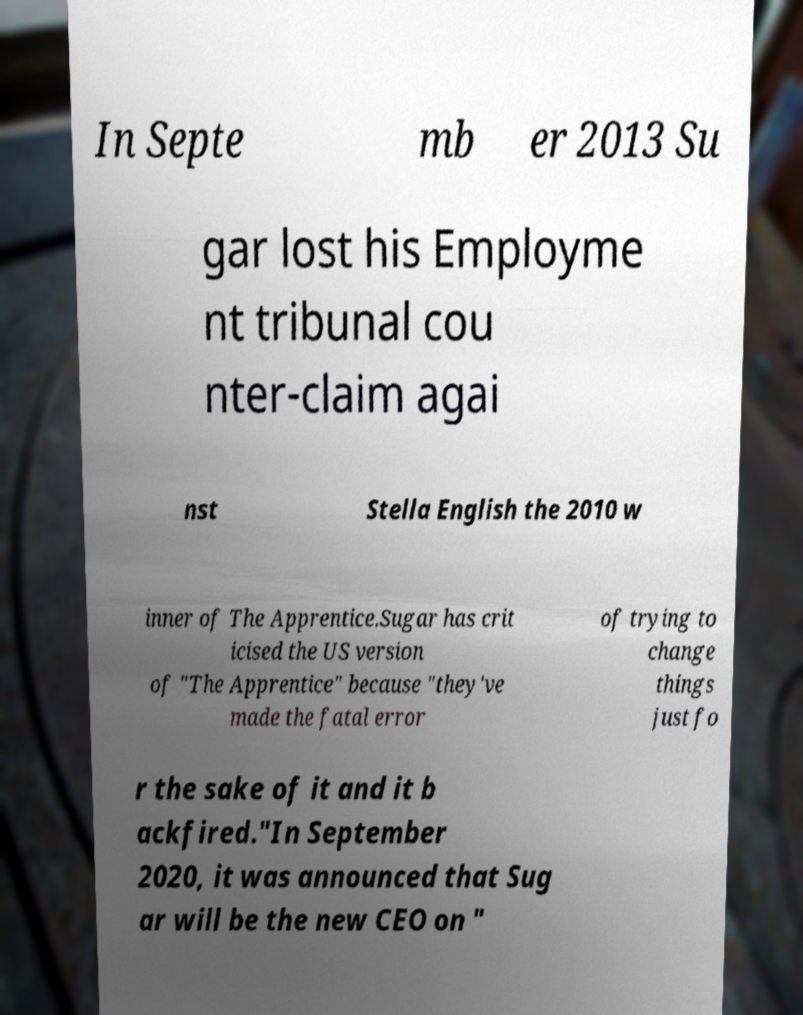Could you assist in decoding the text presented in this image and type it out clearly? In Septe mb er 2013 Su gar lost his Employme nt tribunal cou nter-claim agai nst Stella English the 2010 w inner of The Apprentice.Sugar has crit icised the US version of "The Apprentice" because "they've made the fatal error of trying to change things just fo r the sake of it and it b ackfired."In September 2020, it was announced that Sug ar will be the new CEO on " 